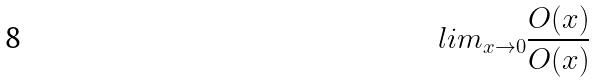Convert formula to latex. <formula><loc_0><loc_0><loc_500><loc_500>l i m _ { x \rightarrow 0 } \frac { O ( x ) } { O ( x ) }</formula> 